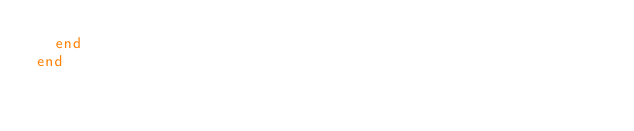Convert code to text. <code><loc_0><loc_0><loc_500><loc_500><_Ruby_>  end
end
</code> 